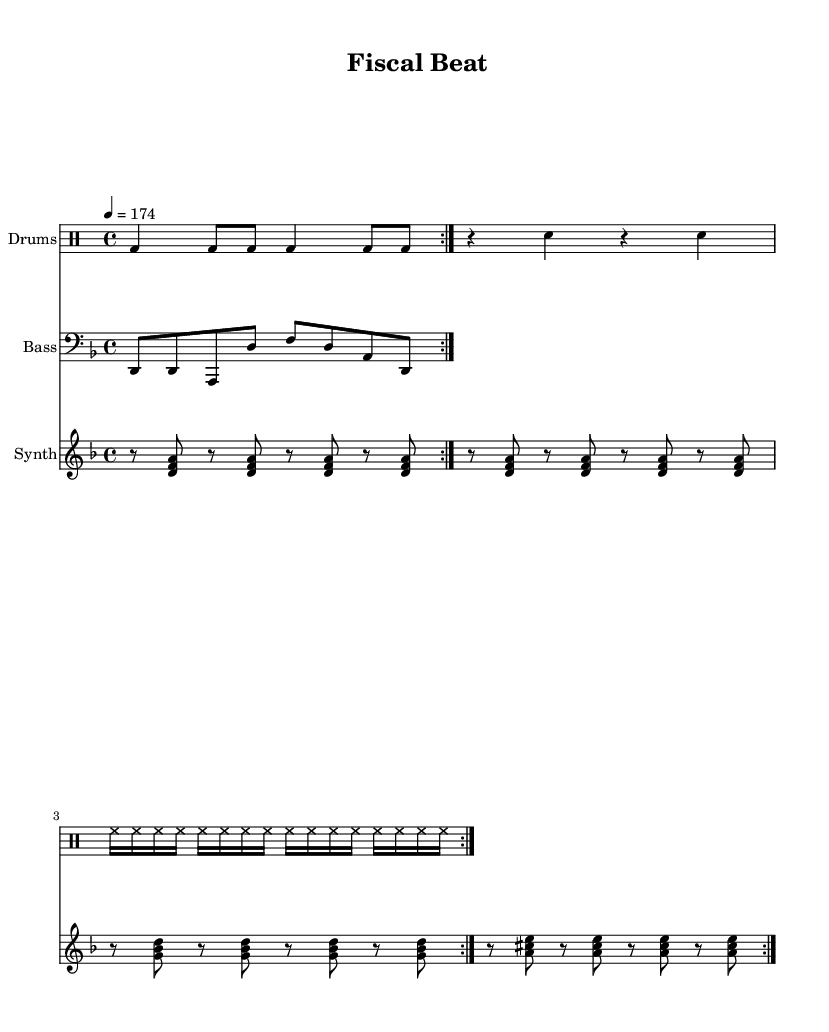What is the key signature of this music? The key signature is indicated by the sharps or flats at the beginning of the staff. The music states "d minor" which translates to one flat.
Answer: D minor What is the time signature of this music? The time signature is found at the beginning of the music and indicates how many beats are in a measure. The "4/4" shows there are 4 beats per measure.
Answer: 4/4 What is the tempo marking for this piece? The tempo marking is given as "4 = 174," which indicates that there are 174 beats per minute, specifying how fast the piece should be played.
Answer: 174 How many measures are repeated in the drum section? The drum part clearly has a repeat marking (volta) that is stated at the beginning of the section indicating it is to be played twice.
Answer: 2 What is the highest note in the synth part? By examining the synth part, the notes are identified, and the highest note is "e," which occurs in the chord <a cis e>.
Answer: e What instruments are used in this piece? The score shows three distinct parts: Drums, Bass, and Synth, displayed as different staves in the music.
Answer: Drums, Bass, Synth What rhythmic pattern do the drums primarily use? The drumming pattern can be observed in the drummode section, primarily using bass drum and snare interactions with a consistent hi-hat sequence. The specific pattern includes four beats with subdivisions and rests creating a dance rhythm.
Answer: Bass drum and snare 